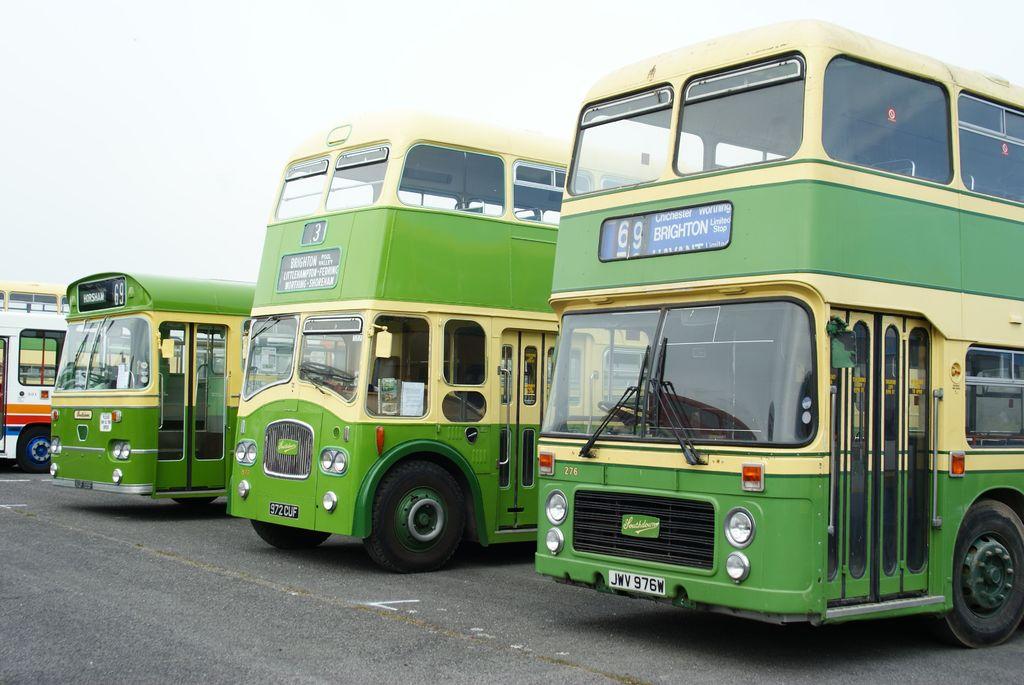What number is on the bus?
Your response must be concise. 69. What is the license plate number?
Offer a terse response. Jwv 976w. 